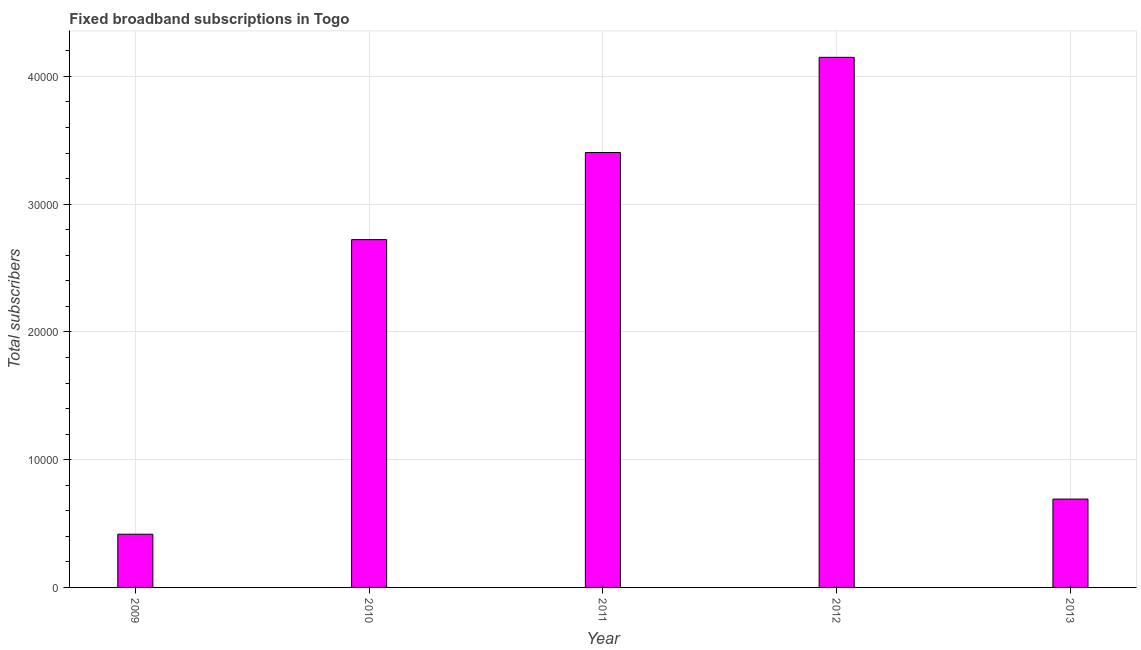Does the graph contain any zero values?
Offer a very short reply. No. Does the graph contain grids?
Your answer should be compact. Yes. What is the title of the graph?
Offer a very short reply. Fixed broadband subscriptions in Togo. What is the label or title of the X-axis?
Give a very brief answer. Year. What is the label or title of the Y-axis?
Your answer should be compact. Total subscribers. What is the total number of fixed broadband subscriptions in 2009?
Provide a succinct answer. 4166. Across all years, what is the maximum total number of fixed broadband subscriptions?
Give a very brief answer. 4.15e+04. Across all years, what is the minimum total number of fixed broadband subscriptions?
Ensure brevity in your answer.  4166. In which year was the total number of fixed broadband subscriptions minimum?
Your response must be concise. 2009. What is the sum of the total number of fixed broadband subscriptions?
Keep it short and to the point. 1.14e+05. What is the difference between the total number of fixed broadband subscriptions in 2012 and 2013?
Your response must be concise. 3.46e+04. What is the average total number of fixed broadband subscriptions per year?
Your response must be concise. 2.28e+04. What is the median total number of fixed broadband subscriptions?
Your answer should be very brief. 2.72e+04. What is the ratio of the total number of fixed broadband subscriptions in 2012 to that in 2013?
Provide a succinct answer. 6. Is the total number of fixed broadband subscriptions in 2009 less than that in 2013?
Give a very brief answer. Yes. What is the difference between the highest and the second highest total number of fixed broadband subscriptions?
Make the answer very short. 7454. What is the difference between the highest and the lowest total number of fixed broadband subscriptions?
Ensure brevity in your answer.  3.73e+04. Are all the bars in the graph horizontal?
Give a very brief answer. No. Are the values on the major ticks of Y-axis written in scientific E-notation?
Make the answer very short. No. What is the Total subscribers of 2009?
Provide a short and direct response. 4166. What is the Total subscribers in 2010?
Your answer should be compact. 2.72e+04. What is the Total subscribers of 2011?
Give a very brief answer. 3.40e+04. What is the Total subscribers of 2012?
Make the answer very short. 4.15e+04. What is the Total subscribers of 2013?
Ensure brevity in your answer.  6915. What is the difference between the Total subscribers in 2009 and 2010?
Provide a succinct answer. -2.31e+04. What is the difference between the Total subscribers in 2009 and 2011?
Keep it short and to the point. -2.99e+04. What is the difference between the Total subscribers in 2009 and 2012?
Offer a terse response. -3.73e+04. What is the difference between the Total subscribers in 2009 and 2013?
Your response must be concise. -2749. What is the difference between the Total subscribers in 2010 and 2011?
Provide a succinct answer. -6814. What is the difference between the Total subscribers in 2010 and 2012?
Your answer should be very brief. -1.43e+04. What is the difference between the Total subscribers in 2010 and 2013?
Provide a succinct answer. 2.03e+04. What is the difference between the Total subscribers in 2011 and 2012?
Provide a succinct answer. -7454. What is the difference between the Total subscribers in 2011 and 2013?
Your answer should be very brief. 2.71e+04. What is the difference between the Total subscribers in 2012 and 2013?
Ensure brevity in your answer.  3.46e+04. What is the ratio of the Total subscribers in 2009 to that in 2010?
Ensure brevity in your answer.  0.15. What is the ratio of the Total subscribers in 2009 to that in 2011?
Provide a short and direct response. 0.12. What is the ratio of the Total subscribers in 2009 to that in 2012?
Your answer should be compact. 0.1. What is the ratio of the Total subscribers in 2009 to that in 2013?
Keep it short and to the point. 0.6. What is the ratio of the Total subscribers in 2010 to that in 2012?
Provide a succinct answer. 0.66. What is the ratio of the Total subscribers in 2010 to that in 2013?
Give a very brief answer. 3.94. What is the ratio of the Total subscribers in 2011 to that in 2012?
Your answer should be compact. 0.82. What is the ratio of the Total subscribers in 2011 to that in 2013?
Your answer should be compact. 4.92. What is the ratio of the Total subscribers in 2012 to that in 2013?
Provide a short and direct response. 6. 